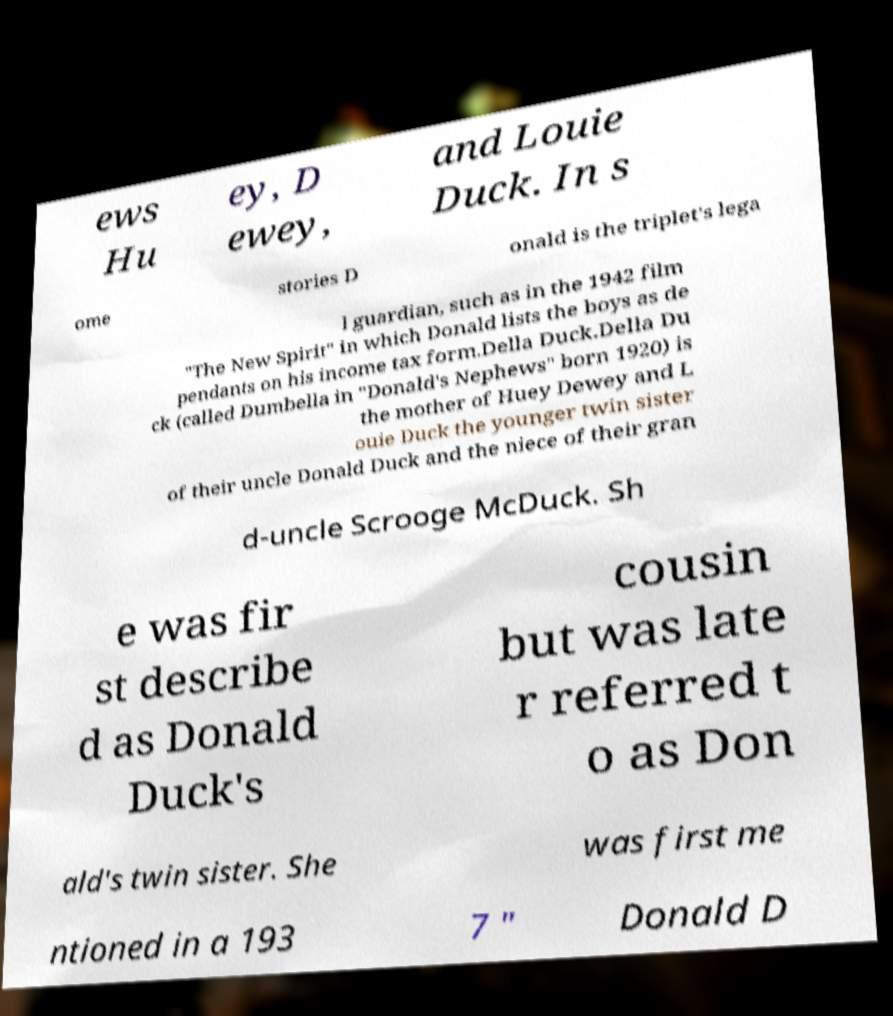Can you read and provide the text displayed in the image?This photo seems to have some interesting text. Can you extract and type it out for me? ews Hu ey, D ewey, and Louie Duck. In s ome stories D onald is the triplet's lega l guardian, such as in the 1942 film "The New Spirit" in which Donald lists the boys as de pendants on his income tax form.Della Duck.Della Du ck (called Dumbella in "Donald's Nephews" born 1920) is the mother of Huey Dewey and L ouie Duck the younger twin sister of their uncle Donald Duck and the niece of their gran d-uncle Scrooge McDuck. Sh e was fir st describe d as Donald Duck's cousin but was late r referred t o as Don ald's twin sister. She was first me ntioned in a 193 7 " Donald D 